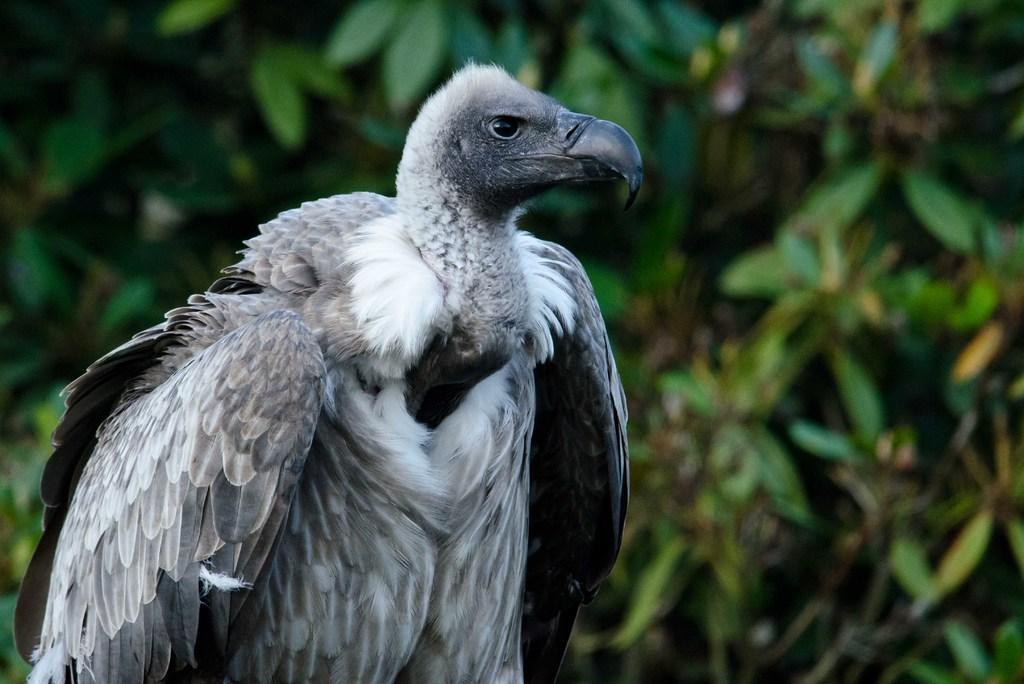Could you give a brief overview of what you see in this image? In this picture I can see a vulture on the left side, in the background there are green leaves. 